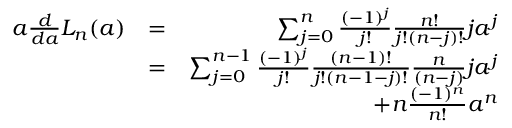Convert formula to latex. <formula><loc_0><loc_0><loc_500><loc_500>\begin{array} { r l r } { a \frac { d } { d a } L _ { n } ( a ) } & { = } & { \sum _ { j = 0 } ^ { n } \frac { ( - 1 ) ^ { j } } { j ! } \frac { n ! } { j ! ( n - j ) ! } j a ^ { j } } \\ & { = } & { \sum _ { j = 0 } ^ { n - 1 } \frac { ( - 1 ) ^ { j } } { j ! } \frac { ( n - 1 ) ! } { j ! ( n - 1 - j ) ! } \frac { n } { ( n - j ) } j a ^ { j } } \\ & { + n \frac { ( - 1 ) ^ { n } } { n ! } a ^ { n } } \end{array}</formula> 